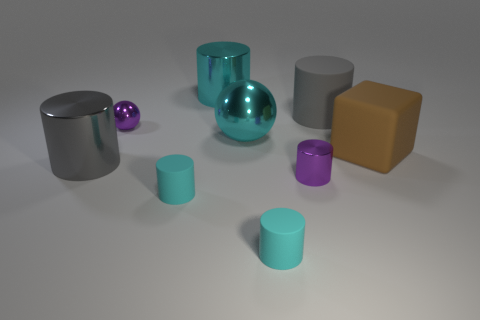Subtract all cyan cylinders. How many were subtracted if there are2cyan cylinders left? 1 Subtract all purple cylinders. How many cylinders are left? 5 Subtract all brown balls. How many cyan cylinders are left? 3 Subtract all cyan cylinders. How many cylinders are left? 3 Subtract 1 spheres. How many spheres are left? 1 Subtract all cylinders. How many objects are left? 3 Subtract all blue balls. Subtract all cyan cylinders. How many balls are left? 2 Add 9 gray rubber things. How many gray rubber things are left? 10 Add 9 purple blocks. How many purple blocks exist? 9 Subtract 0 brown cylinders. How many objects are left? 9 